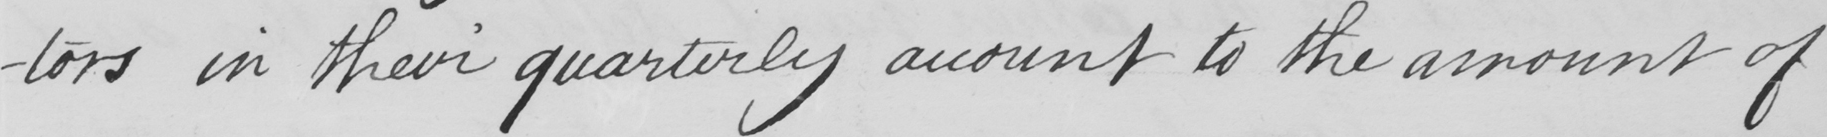What does this handwritten line say? -tors in their quarterly account to the amount of 